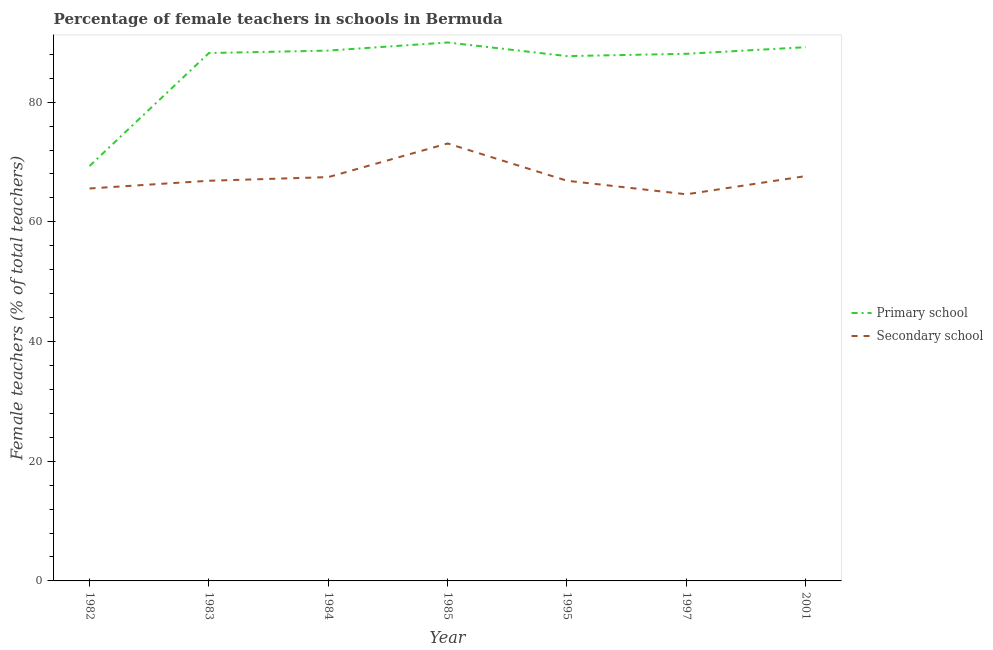Does the line corresponding to percentage of female teachers in primary schools intersect with the line corresponding to percentage of female teachers in secondary schools?
Ensure brevity in your answer.  No. Is the number of lines equal to the number of legend labels?
Keep it short and to the point. Yes. What is the percentage of female teachers in primary schools in 2001?
Give a very brief answer. 89.18. Across all years, what is the maximum percentage of female teachers in primary schools?
Your answer should be compact. 89.97. Across all years, what is the minimum percentage of female teachers in secondary schools?
Make the answer very short. 64.6. In which year was the percentage of female teachers in secondary schools maximum?
Offer a terse response. 1985. In which year was the percentage of female teachers in primary schools minimum?
Make the answer very short. 1982. What is the total percentage of female teachers in primary schools in the graph?
Make the answer very short. 601.04. What is the difference between the percentage of female teachers in secondary schools in 1983 and that in 1984?
Your answer should be compact. -0.61. What is the difference between the percentage of female teachers in secondary schools in 1983 and the percentage of female teachers in primary schools in 1984?
Your answer should be very brief. -21.75. What is the average percentage of female teachers in secondary schools per year?
Keep it short and to the point. 67.44. In the year 1997, what is the difference between the percentage of female teachers in secondary schools and percentage of female teachers in primary schools?
Your answer should be very brief. -23.48. In how many years, is the percentage of female teachers in primary schools greater than 16 %?
Keep it short and to the point. 7. What is the ratio of the percentage of female teachers in secondary schools in 1982 to that in 1984?
Your answer should be very brief. 0.97. Is the percentage of female teachers in secondary schools in 1982 less than that in 1983?
Offer a terse response. Yes. Is the difference between the percentage of female teachers in primary schools in 1984 and 1995 greater than the difference between the percentage of female teachers in secondary schools in 1984 and 1995?
Your answer should be compact. Yes. What is the difference between the highest and the second highest percentage of female teachers in primary schools?
Your answer should be compact. 0.79. What is the difference between the highest and the lowest percentage of female teachers in primary schools?
Provide a short and direct response. 20.64. In how many years, is the percentage of female teachers in primary schools greater than the average percentage of female teachers in primary schools taken over all years?
Provide a succinct answer. 6. Is the percentage of female teachers in primary schools strictly greater than the percentage of female teachers in secondary schools over the years?
Provide a succinct answer. Yes. Is the percentage of female teachers in secondary schools strictly less than the percentage of female teachers in primary schools over the years?
Your answer should be compact. Yes. How many years are there in the graph?
Your response must be concise. 7. Are the values on the major ticks of Y-axis written in scientific E-notation?
Make the answer very short. No. Does the graph contain grids?
Ensure brevity in your answer.  No. How many legend labels are there?
Provide a succinct answer. 2. How are the legend labels stacked?
Give a very brief answer. Vertical. What is the title of the graph?
Make the answer very short. Percentage of female teachers in schools in Bermuda. What is the label or title of the X-axis?
Your answer should be compact. Year. What is the label or title of the Y-axis?
Give a very brief answer. Female teachers (% of total teachers). What is the Female teachers (% of total teachers) in Primary school in 1982?
Provide a succinct answer. 69.33. What is the Female teachers (% of total teachers) in Secondary school in 1982?
Your answer should be very brief. 65.57. What is the Female teachers (% of total teachers) of Primary school in 1983?
Your response must be concise. 88.2. What is the Female teachers (% of total teachers) in Secondary school in 1983?
Ensure brevity in your answer.  66.86. What is the Female teachers (% of total teachers) in Primary school in 1984?
Your answer should be compact. 88.61. What is the Female teachers (% of total teachers) in Secondary school in 1984?
Your answer should be very brief. 67.47. What is the Female teachers (% of total teachers) of Primary school in 1985?
Give a very brief answer. 89.97. What is the Female teachers (% of total teachers) in Secondary school in 1985?
Your answer should be compact. 73.09. What is the Female teachers (% of total teachers) of Primary school in 1995?
Offer a terse response. 87.69. What is the Female teachers (% of total teachers) in Secondary school in 1995?
Provide a short and direct response. 66.87. What is the Female teachers (% of total teachers) in Primary school in 1997?
Keep it short and to the point. 88.08. What is the Female teachers (% of total teachers) in Secondary school in 1997?
Offer a very short reply. 64.6. What is the Female teachers (% of total teachers) of Primary school in 2001?
Offer a terse response. 89.18. What is the Female teachers (% of total teachers) of Secondary school in 2001?
Offer a terse response. 67.64. Across all years, what is the maximum Female teachers (% of total teachers) in Primary school?
Provide a succinct answer. 89.97. Across all years, what is the maximum Female teachers (% of total teachers) in Secondary school?
Keep it short and to the point. 73.09. Across all years, what is the minimum Female teachers (% of total teachers) in Primary school?
Keep it short and to the point. 69.33. Across all years, what is the minimum Female teachers (% of total teachers) of Secondary school?
Make the answer very short. 64.6. What is the total Female teachers (% of total teachers) of Primary school in the graph?
Offer a very short reply. 601.04. What is the total Female teachers (% of total teachers) in Secondary school in the graph?
Your response must be concise. 472.1. What is the difference between the Female teachers (% of total teachers) of Primary school in 1982 and that in 1983?
Offer a terse response. -18.87. What is the difference between the Female teachers (% of total teachers) in Secondary school in 1982 and that in 1983?
Make the answer very short. -1.29. What is the difference between the Female teachers (% of total teachers) of Primary school in 1982 and that in 1984?
Offer a very short reply. -19.28. What is the difference between the Female teachers (% of total teachers) of Secondary school in 1982 and that in 1984?
Provide a succinct answer. -1.9. What is the difference between the Female teachers (% of total teachers) in Primary school in 1982 and that in 1985?
Provide a short and direct response. -20.64. What is the difference between the Female teachers (% of total teachers) in Secondary school in 1982 and that in 1985?
Offer a terse response. -7.52. What is the difference between the Female teachers (% of total teachers) of Primary school in 1982 and that in 1995?
Offer a terse response. -18.36. What is the difference between the Female teachers (% of total teachers) of Secondary school in 1982 and that in 1995?
Make the answer very short. -1.29. What is the difference between the Female teachers (% of total teachers) in Primary school in 1982 and that in 1997?
Provide a succinct answer. -18.75. What is the difference between the Female teachers (% of total teachers) of Secondary school in 1982 and that in 1997?
Offer a terse response. 0.97. What is the difference between the Female teachers (% of total teachers) in Primary school in 1982 and that in 2001?
Provide a succinct answer. -19.85. What is the difference between the Female teachers (% of total teachers) in Secondary school in 1982 and that in 2001?
Offer a terse response. -2.07. What is the difference between the Female teachers (% of total teachers) in Primary school in 1983 and that in 1984?
Keep it short and to the point. -0.41. What is the difference between the Female teachers (% of total teachers) in Secondary school in 1983 and that in 1984?
Keep it short and to the point. -0.61. What is the difference between the Female teachers (% of total teachers) of Primary school in 1983 and that in 1985?
Give a very brief answer. -1.77. What is the difference between the Female teachers (% of total teachers) in Secondary school in 1983 and that in 1985?
Offer a very short reply. -6.23. What is the difference between the Female teachers (% of total teachers) of Primary school in 1983 and that in 1995?
Your response must be concise. 0.51. What is the difference between the Female teachers (% of total teachers) of Secondary school in 1983 and that in 1995?
Your response must be concise. -0. What is the difference between the Female teachers (% of total teachers) of Primary school in 1983 and that in 1997?
Provide a short and direct response. 0.12. What is the difference between the Female teachers (% of total teachers) of Secondary school in 1983 and that in 1997?
Your answer should be compact. 2.26. What is the difference between the Female teachers (% of total teachers) in Primary school in 1983 and that in 2001?
Make the answer very short. -0.98. What is the difference between the Female teachers (% of total teachers) in Secondary school in 1983 and that in 2001?
Ensure brevity in your answer.  -0.78. What is the difference between the Female teachers (% of total teachers) of Primary school in 1984 and that in 1985?
Provide a succinct answer. -1.36. What is the difference between the Female teachers (% of total teachers) in Secondary school in 1984 and that in 1985?
Your answer should be compact. -5.62. What is the difference between the Female teachers (% of total teachers) of Primary school in 1984 and that in 1995?
Provide a succinct answer. 0.92. What is the difference between the Female teachers (% of total teachers) of Secondary school in 1984 and that in 1995?
Keep it short and to the point. 0.6. What is the difference between the Female teachers (% of total teachers) of Primary school in 1984 and that in 1997?
Make the answer very short. 0.53. What is the difference between the Female teachers (% of total teachers) of Secondary school in 1984 and that in 1997?
Offer a terse response. 2.87. What is the difference between the Female teachers (% of total teachers) in Primary school in 1984 and that in 2001?
Offer a terse response. -0.57. What is the difference between the Female teachers (% of total teachers) in Secondary school in 1984 and that in 2001?
Offer a very short reply. -0.17. What is the difference between the Female teachers (% of total teachers) in Primary school in 1985 and that in 1995?
Give a very brief answer. 2.28. What is the difference between the Female teachers (% of total teachers) in Secondary school in 1985 and that in 1995?
Provide a succinct answer. 6.23. What is the difference between the Female teachers (% of total teachers) in Primary school in 1985 and that in 1997?
Provide a succinct answer. 1.89. What is the difference between the Female teachers (% of total teachers) of Secondary school in 1985 and that in 1997?
Your response must be concise. 8.49. What is the difference between the Female teachers (% of total teachers) in Primary school in 1985 and that in 2001?
Make the answer very short. 0.79. What is the difference between the Female teachers (% of total teachers) in Secondary school in 1985 and that in 2001?
Your answer should be compact. 5.45. What is the difference between the Female teachers (% of total teachers) in Primary school in 1995 and that in 1997?
Provide a succinct answer. -0.39. What is the difference between the Female teachers (% of total teachers) of Secondary school in 1995 and that in 1997?
Your answer should be compact. 2.27. What is the difference between the Female teachers (% of total teachers) in Primary school in 1995 and that in 2001?
Provide a succinct answer. -1.49. What is the difference between the Female teachers (% of total teachers) of Secondary school in 1995 and that in 2001?
Provide a short and direct response. -0.78. What is the difference between the Female teachers (% of total teachers) of Primary school in 1997 and that in 2001?
Ensure brevity in your answer.  -1.1. What is the difference between the Female teachers (% of total teachers) of Secondary school in 1997 and that in 2001?
Give a very brief answer. -3.04. What is the difference between the Female teachers (% of total teachers) of Primary school in 1982 and the Female teachers (% of total teachers) of Secondary school in 1983?
Ensure brevity in your answer.  2.46. What is the difference between the Female teachers (% of total teachers) in Primary school in 1982 and the Female teachers (% of total teachers) in Secondary school in 1984?
Offer a very short reply. 1.86. What is the difference between the Female teachers (% of total teachers) in Primary school in 1982 and the Female teachers (% of total teachers) in Secondary school in 1985?
Ensure brevity in your answer.  -3.77. What is the difference between the Female teachers (% of total teachers) of Primary school in 1982 and the Female teachers (% of total teachers) of Secondary school in 1995?
Ensure brevity in your answer.  2.46. What is the difference between the Female teachers (% of total teachers) of Primary school in 1982 and the Female teachers (% of total teachers) of Secondary school in 1997?
Your answer should be compact. 4.73. What is the difference between the Female teachers (% of total teachers) of Primary school in 1982 and the Female teachers (% of total teachers) of Secondary school in 2001?
Give a very brief answer. 1.68. What is the difference between the Female teachers (% of total teachers) in Primary school in 1983 and the Female teachers (% of total teachers) in Secondary school in 1984?
Give a very brief answer. 20.73. What is the difference between the Female teachers (% of total teachers) in Primary school in 1983 and the Female teachers (% of total teachers) in Secondary school in 1985?
Ensure brevity in your answer.  15.11. What is the difference between the Female teachers (% of total teachers) of Primary school in 1983 and the Female teachers (% of total teachers) of Secondary school in 1995?
Your answer should be compact. 21.33. What is the difference between the Female teachers (% of total teachers) in Primary school in 1983 and the Female teachers (% of total teachers) in Secondary school in 1997?
Offer a terse response. 23.6. What is the difference between the Female teachers (% of total teachers) in Primary school in 1983 and the Female teachers (% of total teachers) in Secondary school in 2001?
Your response must be concise. 20.56. What is the difference between the Female teachers (% of total teachers) of Primary school in 1984 and the Female teachers (% of total teachers) of Secondary school in 1985?
Your answer should be very brief. 15.52. What is the difference between the Female teachers (% of total teachers) of Primary school in 1984 and the Female teachers (% of total teachers) of Secondary school in 1995?
Offer a very short reply. 21.74. What is the difference between the Female teachers (% of total teachers) of Primary school in 1984 and the Female teachers (% of total teachers) of Secondary school in 1997?
Offer a terse response. 24.01. What is the difference between the Female teachers (% of total teachers) of Primary school in 1984 and the Female teachers (% of total teachers) of Secondary school in 2001?
Your answer should be compact. 20.96. What is the difference between the Female teachers (% of total teachers) of Primary school in 1985 and the Female teachers (% of total teachers) of Secondary school in 1995?
Your response must be concise. 23.1. What is the difference between the Female teachers (% of total teachers) in Primary school in 1985 and the Female teachers (% of total teachers) in Secondary school in 1997?
Your answer should be very brief. 25.37. What is the difference between the Female teachers (% of total teachers) in Primary school in 1985 and the Female teachers (% of total teachers) in Secondary school in 2001?
Provide a succinct answer. 22.32. What is the difference between the Female teachers (% of total teachers) in Primary school in 1995 and the Female teachers (% of total teachers) in Secondary school in 1997?
Keep it short and to the point. 23.09. What is the difference between the Female teachers (% of total teachers) of Primary school in 1995 and the Female teachers (% of total teachers) of Secondary school in 2001?
Give a very brief answer. 20.05. What is the difference between the Female teachers (% of total teachers) of Primary school in 1997 and the Female teachers (% of total teachers) of Secondary school in 2001?
Your response must be concise. 20.43. What is the average Female teachers (% of total teachers) of Primary school per year?
Offer a very short reply. 85.86. What is the average Female teachers (% of total teachers) in Secondary school per year?
Your answer should be compact. 67.44. In the year 1982, what is the difference between the Female teachers (% of total teachers) of Primary school and Female teachers (% of total teachers) of Secondary school?
Offer a very short reply. 3.75. In the year 1983, what is the difference between the Female teachers (% of total teachers) of Primary school and Female teachers (% of total teachers) of Secondary school?
Provide a short and direct response. 21.34. In the year 1984, what is the difference between the Female teachers (% of total teachers) of Primary school and Female teachers (% of total teachers) of Secondary school?
Give a very brief answer. 21.14. In the year 1985, what is the difference between the Female teachers (% of total teachers) in Primary school and Female teachers (% of total teachers) in Secondary school?
Offer a terse response. 16.88. In the year 1995, what is the difference between the Female teachers (% of total teachers) in Primary school and Female teachers (% of total teachers) in Secondary school?
Provide a succinct answer. 20.82. In the year 1997, what is the difference between the Female teachers (% of total teachers) in Primary school and Female teachers (% of total teachers) in Secondary school?
Offer a terse response. 23.48. In the year 2001, what is the difference between the Female teachers (% of total teachers) of Primary school and Female teachers (% of total teachers) of Secondary school?
Give a very brief answer. 21.54. What is the ratio of the Female teachers (% of total teachers) in Primary school in 1982 to that in 1983?
Offer a very short reply. 0.79. What is the ratio of the Female teachers (% of total teachers) in Secondary school in 1982 to that in 1983?
Your answer should be compact. 0.98. What is the ratio of the Female teachers (% of total teachers) of Primary school in 1982 to that in 1984?
Offer a terse response. 0.78. What is the ratio of the Female teachers (% of total teachers) of Secondary school in 1982 to that in 1984?
Your answer should be very brief. 0.97. What is the ratio of the Female teachers (% of total teachers) of Primary school in 1982 to that in 1985?
Your answer should be compact. 0.77. What is the ratio of the Female teachers (% of total teachers) of Secondary school in 1982 to that in 1985?
Provide a short and direct response. 0.9. What is the ratio of the Female teachers (% of total teachers) in Primary school in 1982 to that in 1995?
Offer a terse response. 0.79. What is the ratio of the Female teachers (% of total teachers) of Secondary school in 1982 to that in 1995?
Make the answer very short. 0.98. What is the ratio of the Female teachers (% of total teachers) in Primary school in 1982 to that in 1997?
Offer a terse response. 0.79. What is the ratio of the Female teachers (% of total teachers) in Secondary school in 1982 to that in 1997?
Make the answer very short. 1.02. What is the ratio of the Female teachers (% of total teachers) in Primary school in 1982 to that in 2001?
Provide a short and direct response. 0.78. What is the ratio of the Female teachers (% of total teachers) in Secondary school in 1982 to that in 2001?
Provide a short and direct response. 0.97. What is the ratio of the Female teachers (% of total teachers) of Secondary school in 1983 to that in 1984?
Provide a short and direct response. 0.99. What is the ratio of the Female teachers (% of total teachers) of Primary school in 1983 to that in 1985?
Offer a terse response. 0.98. What is the ratio of the Female teachers (% of total teachers) in Secondary school in 1983 to that in 1985?
Your answer should be compact. 0.91. What is the ratio of the Female teachers (% of total teachers) of Primary school in 1983 to that in 1995?
Your response must be concise. 1.01. What is the ratio of the Female teachers (% of total teachers) of Primary school in 1983 to that in 1997?
Keep it short and to the point. 1. What is the ratio of the Female teachers (% of total teachers) in Secondary school in 1983 to that in 1997?
Offer a terse response. 1.03. What is the ratio of the Female teachers (% of total teachers) of Secondary school in 1983 to that in 2001?
Provide a short and direct response. 0.99. What is the ratio of the Female teachers (% of total teachers) of Primary school in 1984 to that in 1985?
Keep it short and to the point. 0.98. What is the ratio of the Female teachers (% of total teachers) of Primary school in 1984 to that in 1995?
Offer a terse response. 1.01. What is the ratio of the Female teachers (% of total teachers) of Secondary school in 1984 to that in 1995?
Provide a short and direct response. 1.01. What is the ratio of the Female teachers (% of total teachers) in Secondary school in 1984 to that in 1997?
Ensure brevity in your answer.  1.04. What is the ratio of the Female teachers (% of total teachers) of Primary school in 1984 to that in 2001?
Your answer should be compact. 0.99. What is the ratio of the Female teachers (% of total teachers) of Secondary school in 1984 to that in 2001?
Your answer should be compact. 1. What is the ratio of the Female teachers (% of total teachers) of Primary school in 1985 to that in 1995?
Make the answer very short. 1.03. What is the ratio of the Female teachers (% of total teachers) of Secondary school in 1985 to that in 1995?
Give a very brief answer. 1.09. What is the ratio of the Female teachers (% of total teachers) of Primary school in 1985 to that in 1997?
Provide a short and direct response. 1.02. What is the ratio of the Female teachers (% of total teachers) in Secondary school in 1985 to that in 1997?
Provide a short and direct response. 1.13. What is the ratio of the Female teachers (% of total teachers) in Primary school in 1985 to that in 2001?
Offer a very short reply. 1.01. What is the ratio of the Female teachers (% of total teachers) in Secondary school in 1985 to that in 2001?
Ensure brevity in your answer.  1.08. What is the ratio of the Female teachers (% of total teachers) in Primary school in 1995 to that in 1997?
Offer a terse response. 1. What is the ratio of the Female teachers (% of total teachers) in Secondary school in 1995 to that in 1997?
Your answer should be compact. 1.04. What is the ratio of the Female teachers (% of total teachers) in Primary school in 1995 to that in 2001?
Your answer should be very brief. 0.98. What is the ratio of the Female teachers (% of total teachers) in Primary school in 1997 to that in 2001?
Make the answer very short. 0.99. What is the ratio of the Female teachers (% of total teachers) of Secondary school in 1997 to that in 2001?
Provide a short and direct response. 0.95. What is the difference between the highest and the second highest Female teachers (% of total teachers) of Primary school?
Provide a short and direct response. 0.79. What is the difference between the highest and the second highest Female teachers (% of total teachers) in Secondary school?
Your answer should be very brief. 5.45. What is the difference between the highest and the lowest Female teachers (% of total teachers) of Primary school?
Give a very brief answer. 20.64. What is the difference between the highest and the lowest Female teachers (% of total teachers) in Secondary school?
Your answer should be very brief. 8.49. 